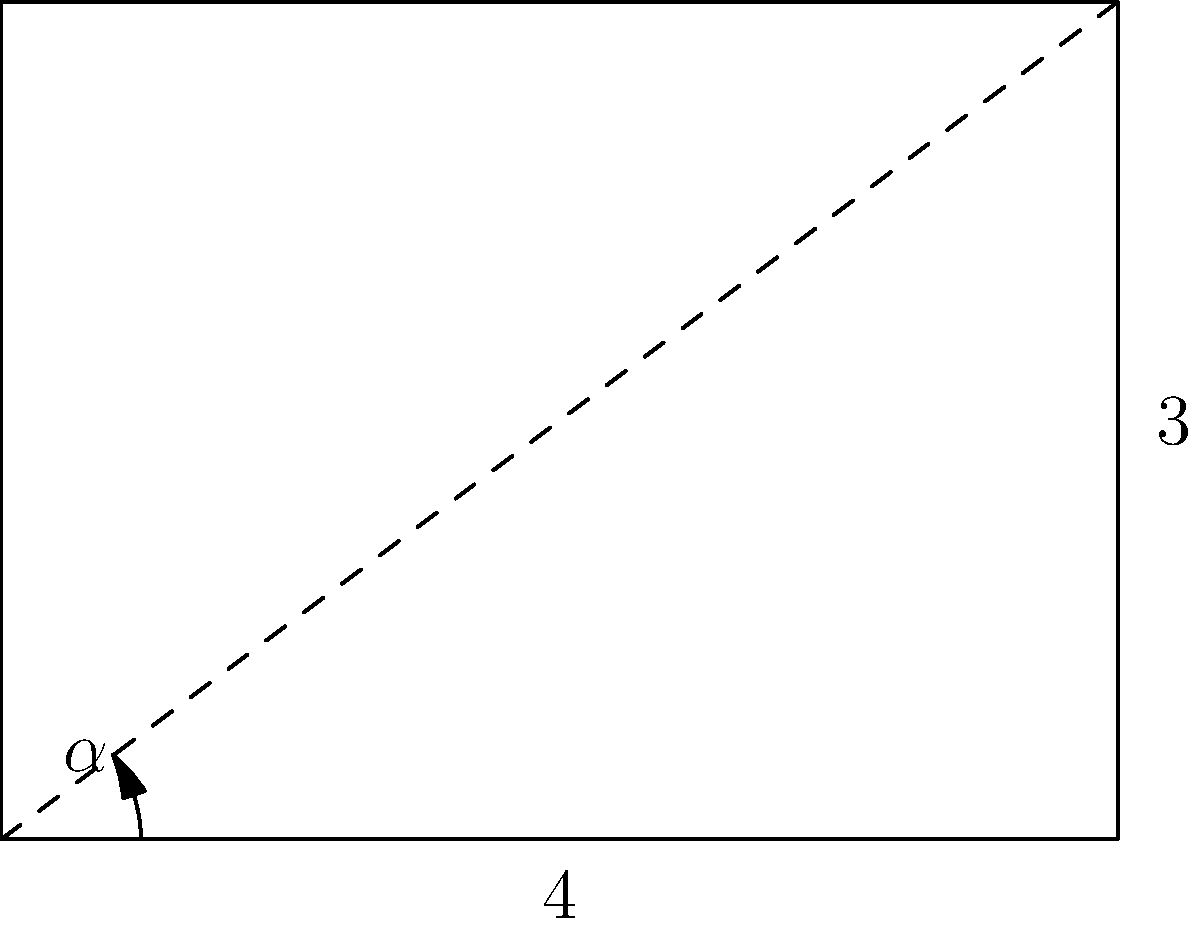In analyzing the geometric composition of a classic East German film poster, you notice a diagonal line drawn from the bottom-left corner to the top-right corner. If the poster has a width of 4 units and a height of 3 units, what is the measure of the angle $\alpha$ formed between this diagonal line and the bottom edge of the poster? How might this angle relate to the film's themes of rising tension or societal progress? To solve this problem, we'll use basic trigonometry:

1. The poster forms a right triangle with the diagonal line.
2. We know the base (width) is 4 units and the height is 3 units.
3. To find angle $\alpha$, we can use the arctangent function:

   $\alpha = \arctan(\frac{\text{opposite}}{\text{adjacent}}) = \arctan(\frac{\text{height}}{\text{width}})$

4. Plugging in our values:
   
   $\alpha = \arctan(\frac{3}{4})$

5. Using a calculator or trigonometric tables:
   
   $\alpha \approx 36.87°$

6. Rounding to the nearest degree:
   
   $\alpha \approx 37°$

This angle of approximately 37° could symbolize the gradual but steady rise of tension or progress in East German society, as depicted in many films of the era. The diagonal line, forming this specific angle, might represent the path from the bottom (oppression, hardship) to the top-right (hope, advancement), reflecting common themes in East German cinema.
Answer: 37° 